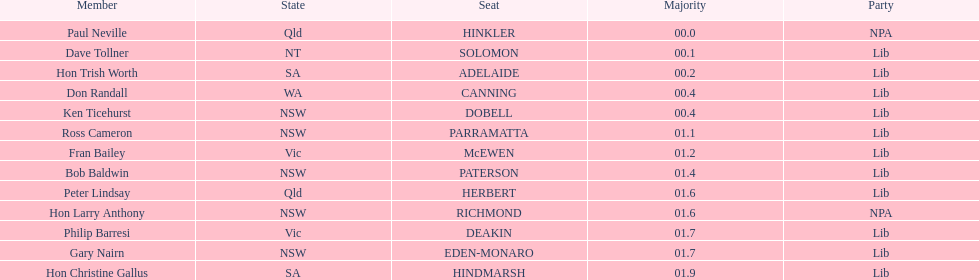Was fran bailey from vic or wa? Vic. 